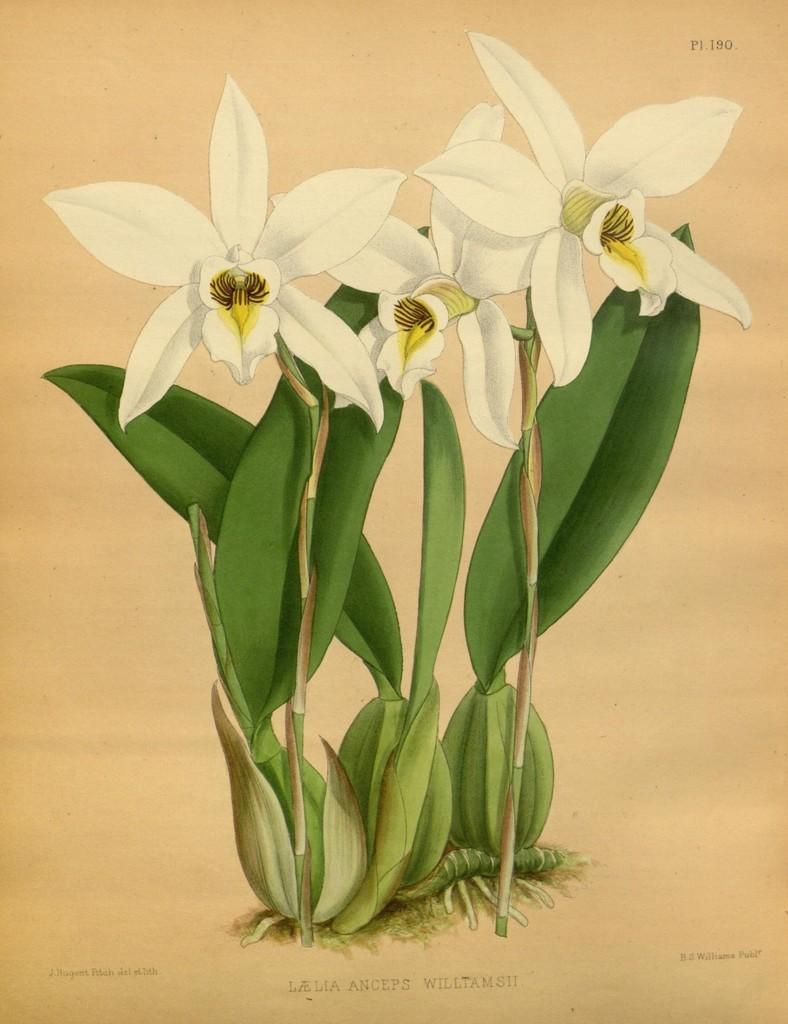What type of artwork is depicted in the image? The image is a painting. What is the main subject of the painting? There are flowers in the painting. What else can be observed about the flowers in the painting? The flowers have leaves. Is there any text present in the painting? Yes, there is text present in the painting. What type of meal is being prepared in the painting? There is no meal being prepared in the painting; it features flowers with leaves and text. Is there any poison present in the painting? There is no mention or indication of poison in the painting, which primarily focuses on flowers, leaves, and text. 